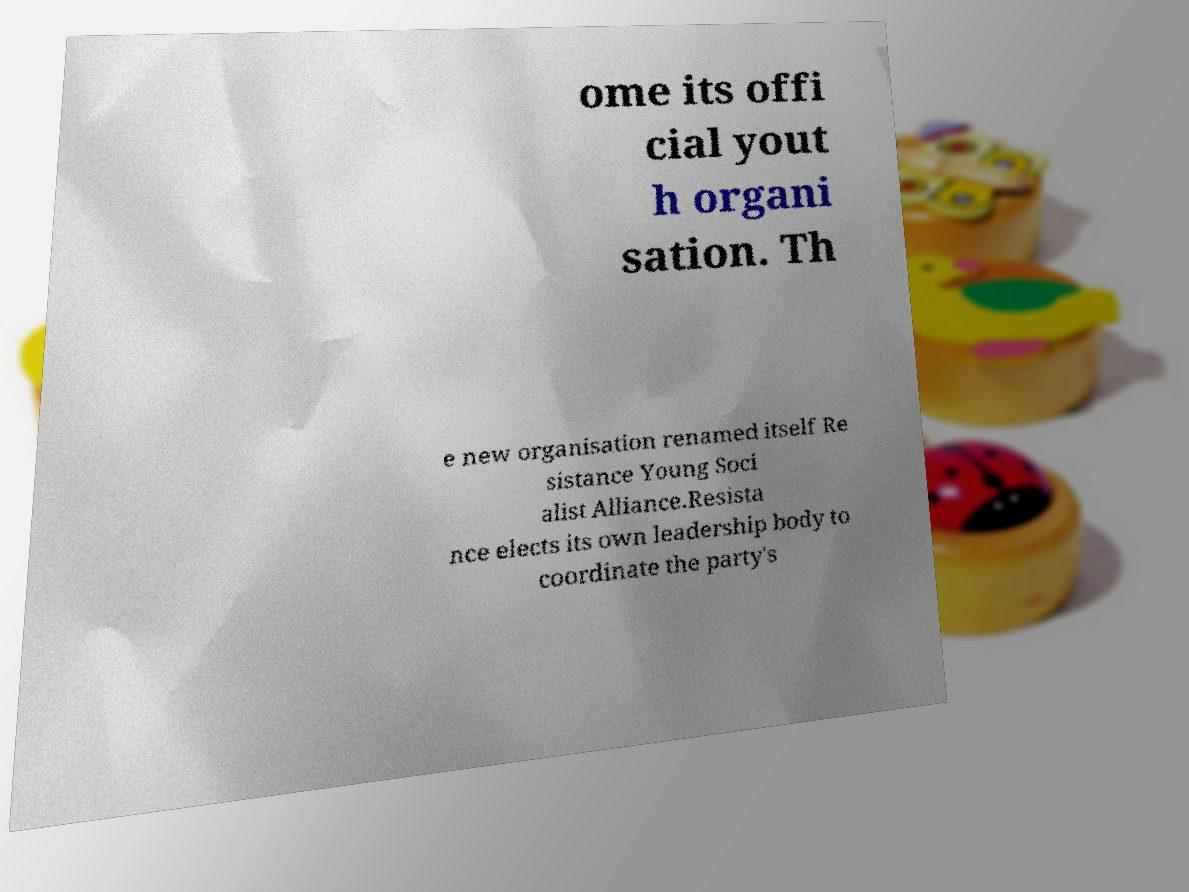Could you extract and type out the text from this image? ome its offi cial yout h organi sation. Th e new organisation renamed itself Re sistance Young Soci alist Alliance.Resista nce elects its own leadership body to coordinate the party's 